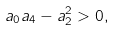Convert formula to latex. <formula><loc_0><loc_0><loc_500><loc_500>a _ { 0 } a _ { 4 } - a _ { 2 } ^ { 2 } > 0 ,</formula> 